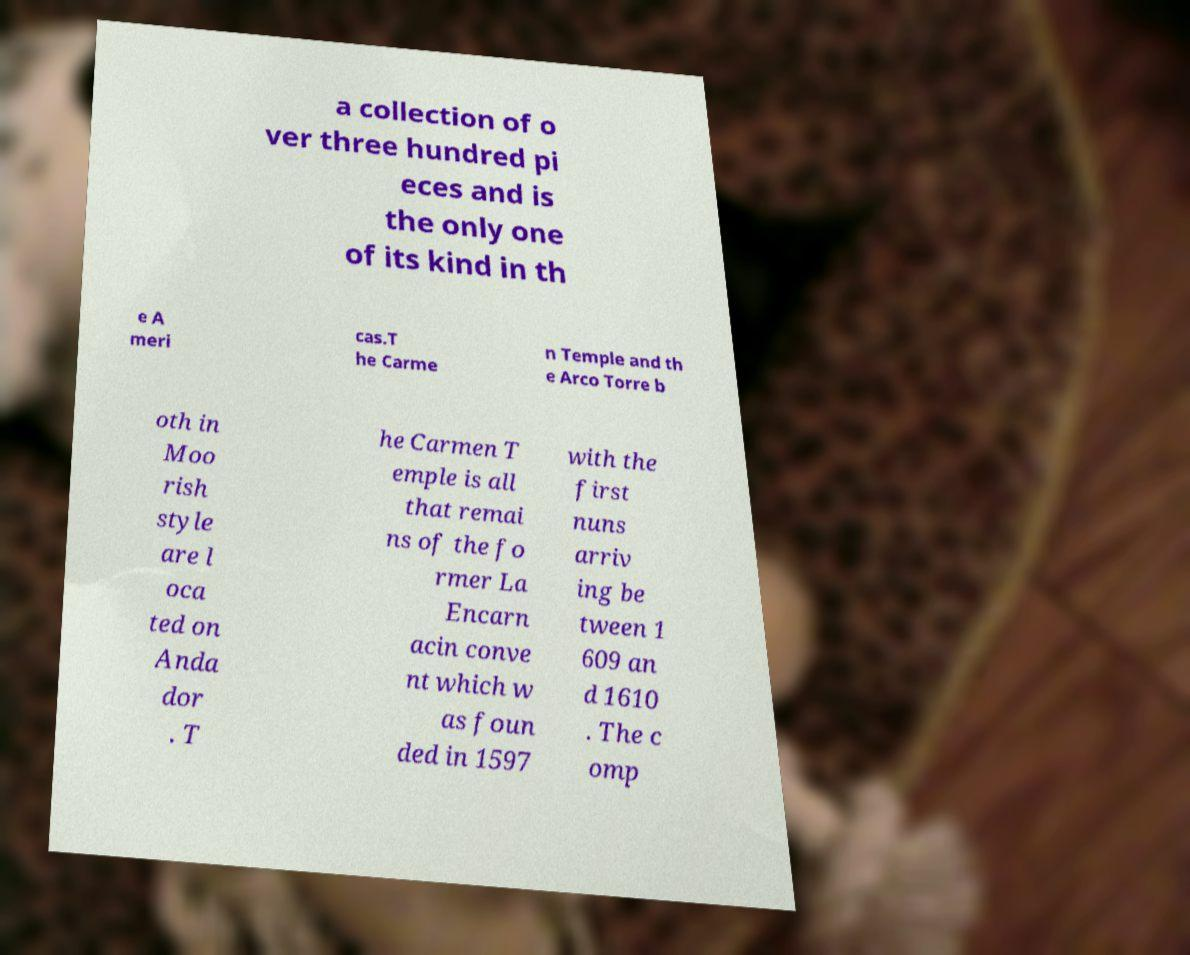Can you read and provide the text displayed in the image?This photo seems to have some interesting text. Can you extract and type it out for me? a collection of o ver three hundred pi eces and is the only one of its kind in th e A meri cas.T he Carme n Temple and th e Arco Torre b oth in Moo rish style are l oca ted on Anda dor . T he Carmen T emple is all that remai ns of the fo rmer La Encarn acin conve nt which w as foun ded in 1597 with the first nuns arriv ing be tween 1 609 an d 1610 . The c omp 